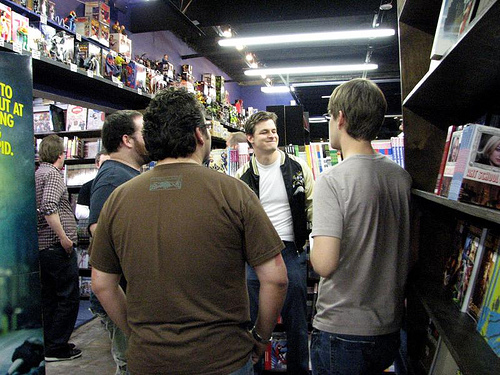<image>
Is there a man to the left of the another man? Yes. From this viewpoint, the man is positioned to the left side relative to the another man. Where is the man in relation to the light? Is it under the light? No. The man is not positioned under the light. The vertical relationship between these objects is different. Where is the book in relation to the cupboard? Is it in front of the cupboard? No. The book is not in front of the cupboard. The spatial positioning shows a different relationship between these objects. Is there a book above the man? No. The book is not positioned above the man. The vertical arrangement shows a different relationship. 